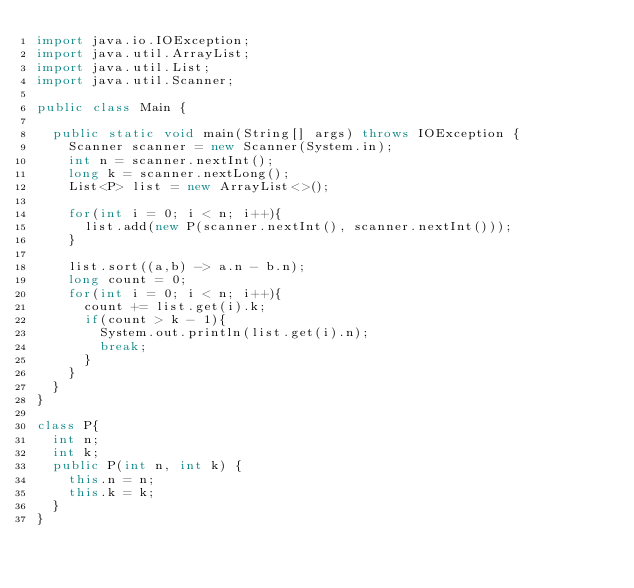Convert code to text. <code><loc_0><loc_0><loc_500><loc_500><_Java_>import java.io.IOException;
import java.util.ArrayList;
import java.util.List;
import java.util.Scanner;

public class Main {

	public static void main(String[] args) throws IOException {
		Scanner scanner = new Scanner(System.in);
		int n = scanner.nextInt();
		long k = scanner.nextLong();
		List<P> list = new ArrayList<>();

		for(int i = 0; i < n; i++){
			list.add(new P(scanner.nextInt(), scanner.nextInt()));
		}

		list.sort((a,b) -> a.n - b.n);
		long count = 0;
		for(int i = 0; i < n; i++){
			count += list.get(i).k;
			if(count > k - 1){
				System.out.println(list.get(i).n);
				break;
			}
		}
	}
}

class P{
	int n;
	int k;
	public P(int n, int k) {
		this.n = n;
		this.k = k;
	}
}</code> 